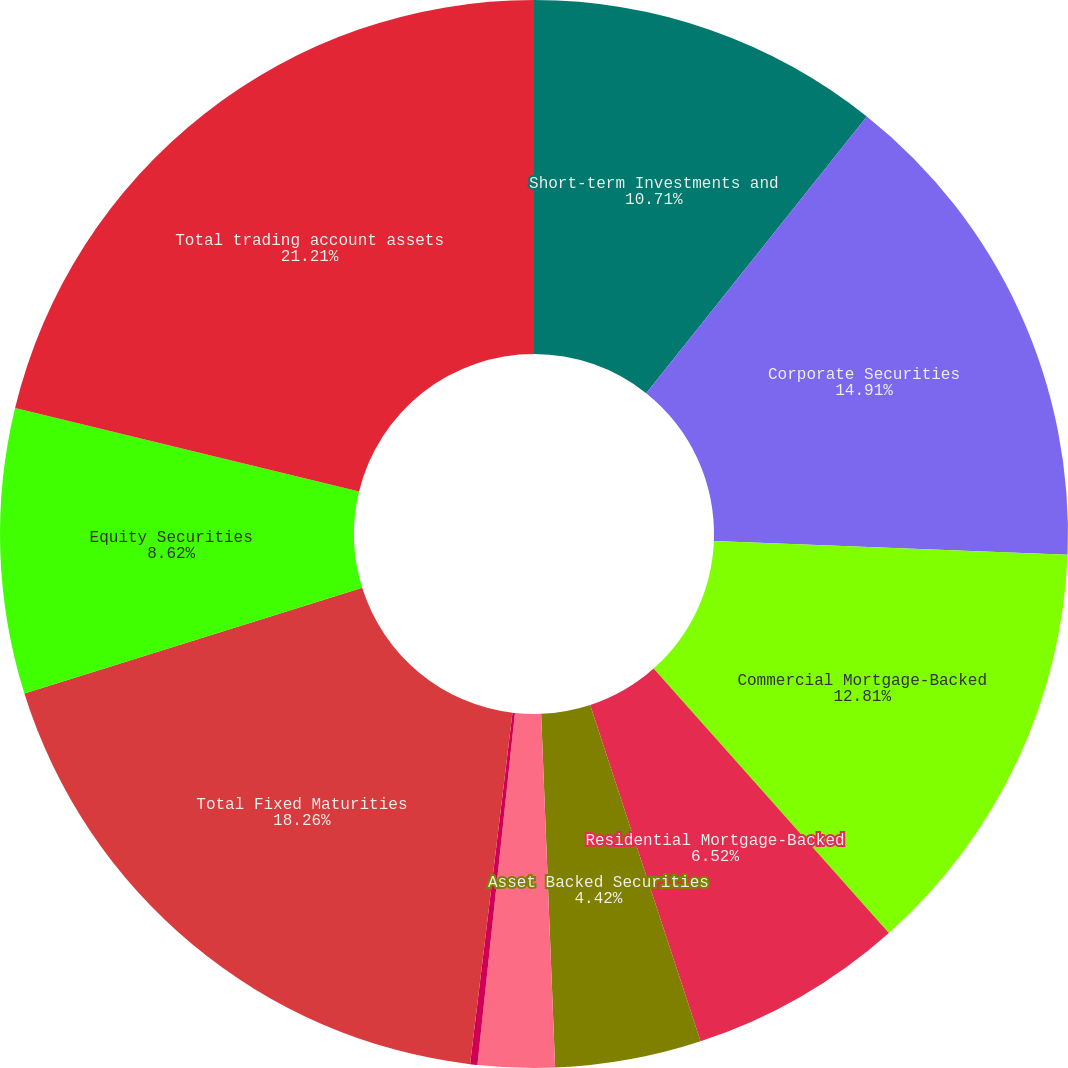Convert chart. <chart><loc_0><loc_0><loc_500><loc_500><pie_chart><fcel>Short-term Investments and<fcel>Corporate Securities<fcel>Commercial Mortgage-Backed<fcel>Residential Mortgage-Backed<fcel>Asset Backed Securities<fcel>Foreign Government<fcel>US Government<fcel>Total Fixed Maturities<fcel>Equity Securities<fcel>Total trading account assets<nl><fcel>10.71%<fcel>14.91%<fcel>12.81%<fcel>6.52%<fcel>4.42%<fcel>2.32%<fcel>0.22%<fcel>18.26%<fcel>8.62%<fcel>21.21%<nl></chart> 